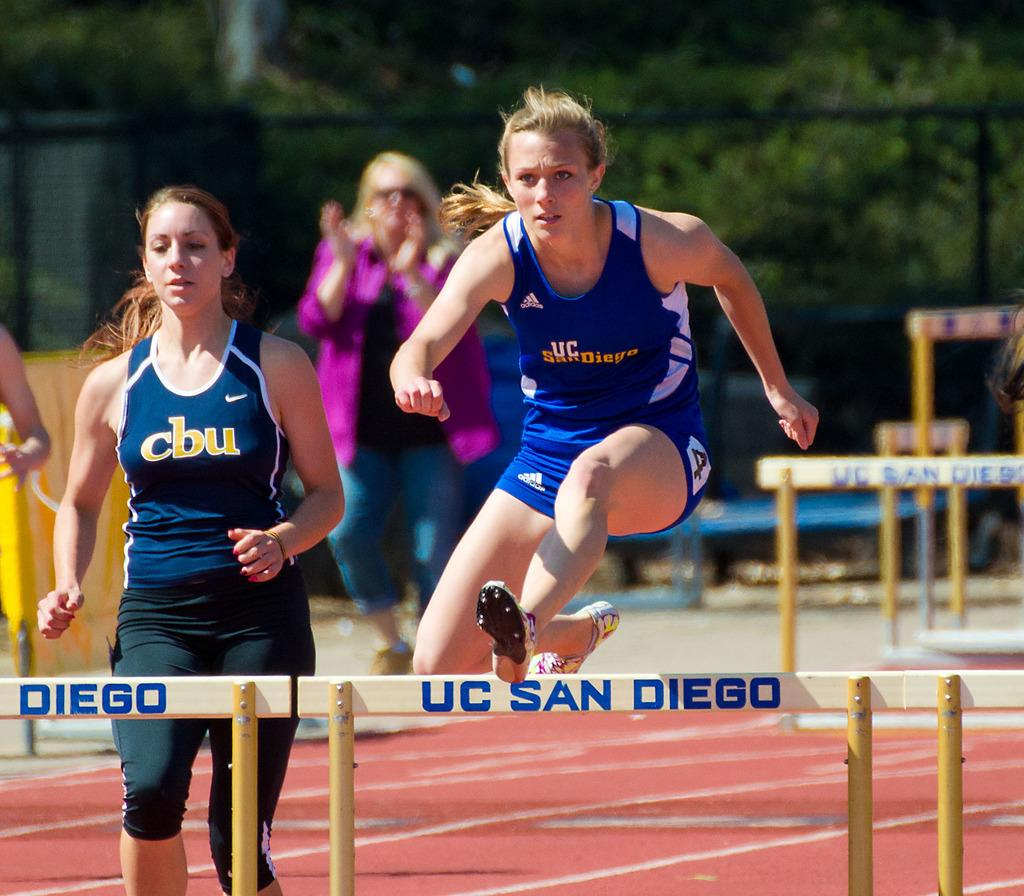<image>
Provide a brief description of the given image. A woman from UC San Diego jumps a hurdle, wile a woman from cbu races to catch up. 